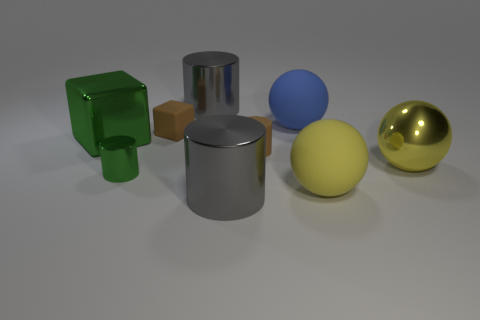Add 1 tiny matte cylinders. How many objects exist? 10 Subtract all cubes. How many objects are left? 7 Add 9 large yellow rubber spheres. How many large yellow rubber spheres are left? 10 Add 5 tiny green objects. How many tiny green objects exist? 6 Subtract 0 gray cubes. How many objects are left? 9 Subtract all green objects. Subtract all tiny gray balls. How many objects are left? 7 